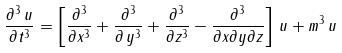Convert formula to latex. <formula><loc_0><loc_0><loc_500><loc_500>\frac { \partial ^ { 3 } \, u } { \partial t ^ { 3 } } = \left [ \frac { \partial ^ { 3 } } { \partial x ^ { 3 } } + \frac { \partial ^ { 3 } } { \partial \, y ^ { 3 } } + \frac { \partial ^ { 3 } } { \partial z ^ { 3 } } - \frac { \partial ^ { 3 } } { \partial x \partial y \partial z } \right ] \, u + m ^ { 3 } \, u</formula> 